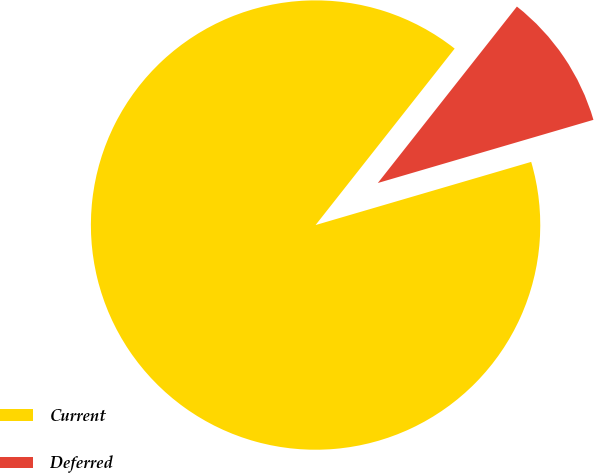Convert chart to OTSL. <chart><loc_0><loc_0><loc_500><loc_500><pie_chart><fcel>Current<fcel>Deferred<nl><fcel>90.16%<fcel>9.84%<nl></chart> 